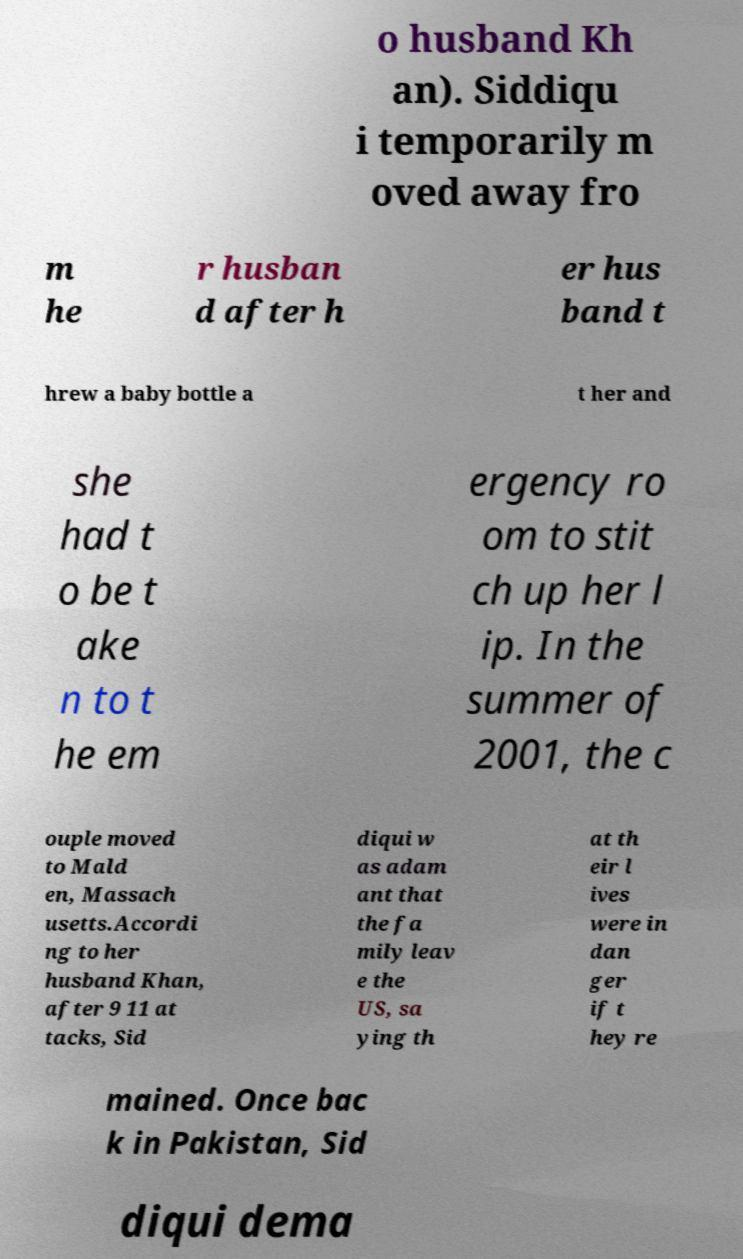For documentation purposes, I need the text within this image transcribed. Could you provide that? o husband Kh an). Siddiqu i temporarily m oved away fro m he r husban d after h er hus band t hrew a baby bottle a t her and she had t o be t ake n to t he em ergency ro om to stit ch up her l ip. In the summer of 2001, the c ouple moved to Mald en, Massach usetts.Accordi ng to her husband Khan, after 9 11 at tacks, Sid diqui w as adam ant that the fa mily leav e the US, sa ying th at th eir l ives were in dan ger if t hey re mained. Once bac k in Pakistan, Sid diqui dema 